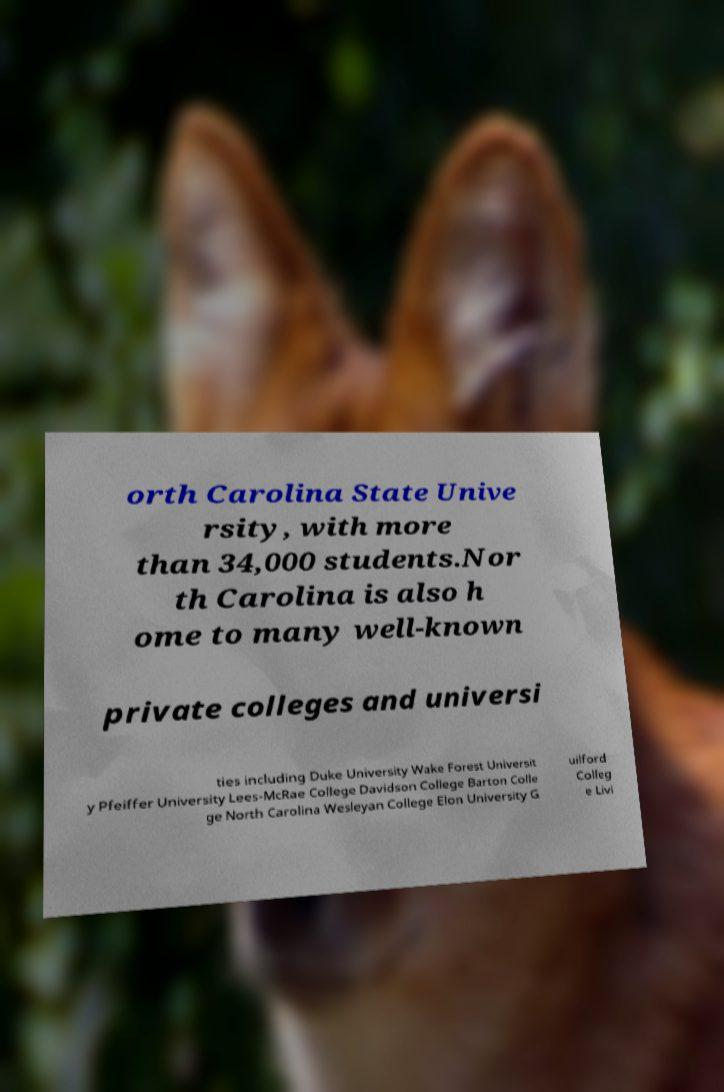Please read and relay the text visible in this image. What does it say? orth Carolina State Unive rsity, with more than 34,000 students.Nor th Carolina is also h ome to many well-known private colleges and universi ties including Duke University Wake Forest Universit y Pfeiffer University Lees-McRae College Davidson College Barton Colle ge North Carolina Wesleyan College Elon University G uilford Colleg e Livi 